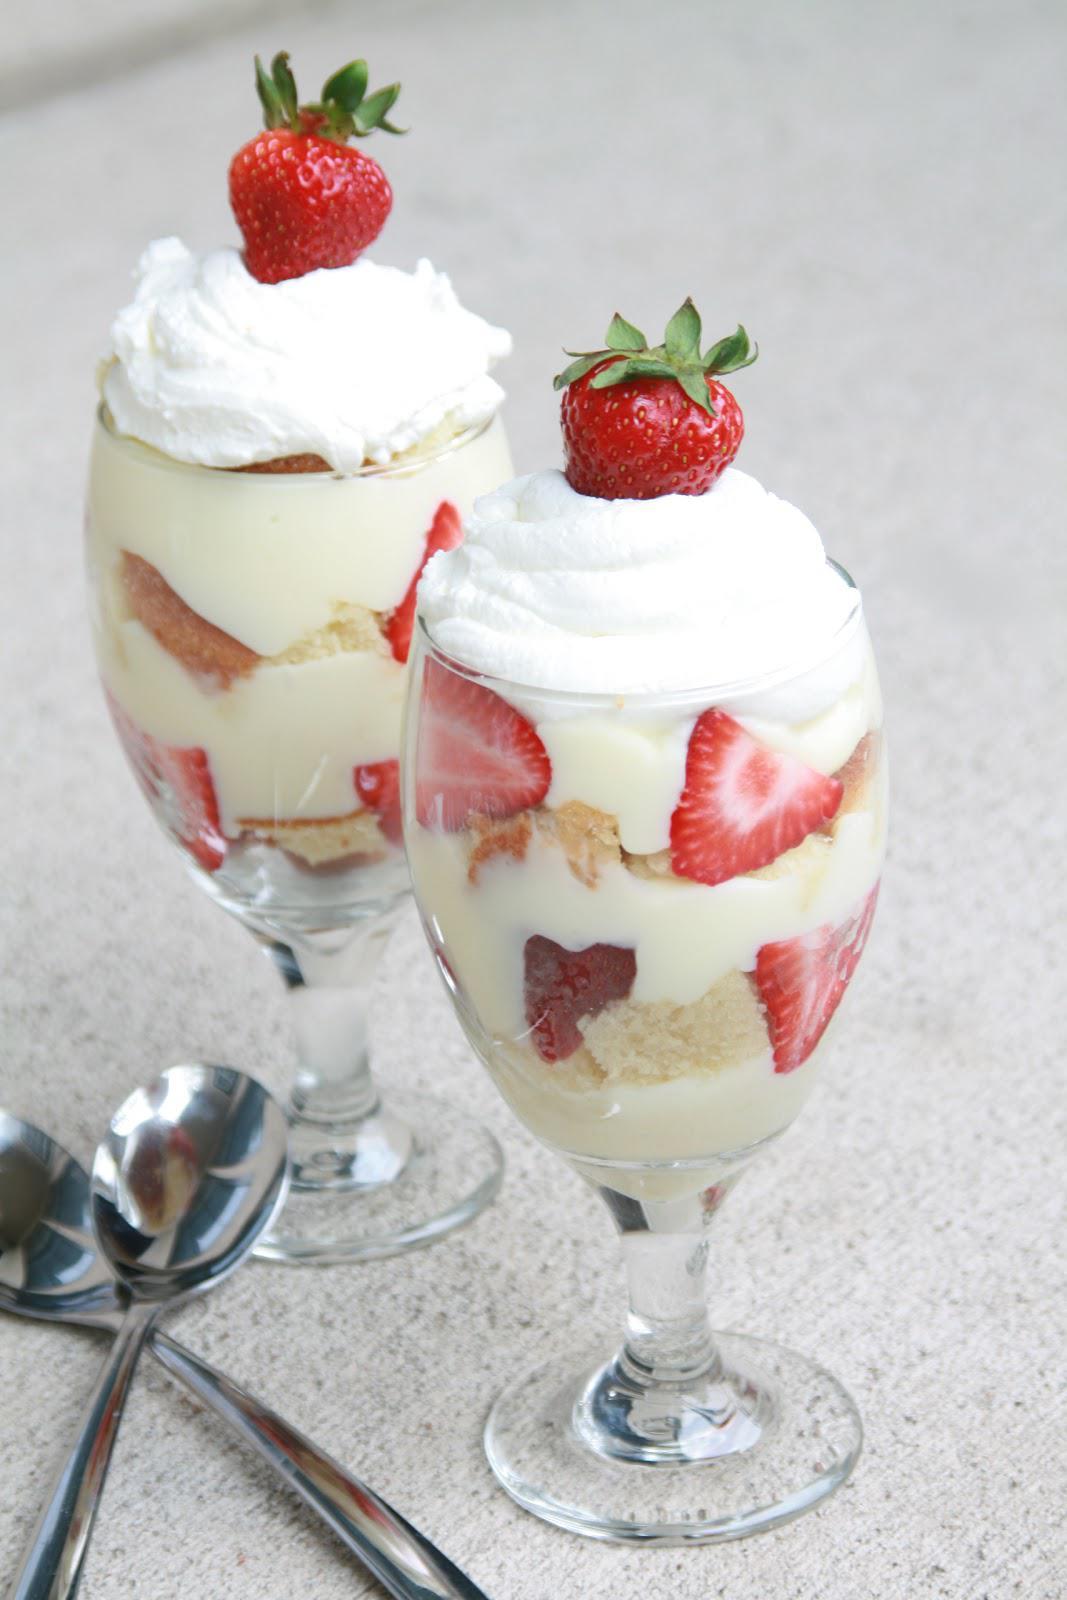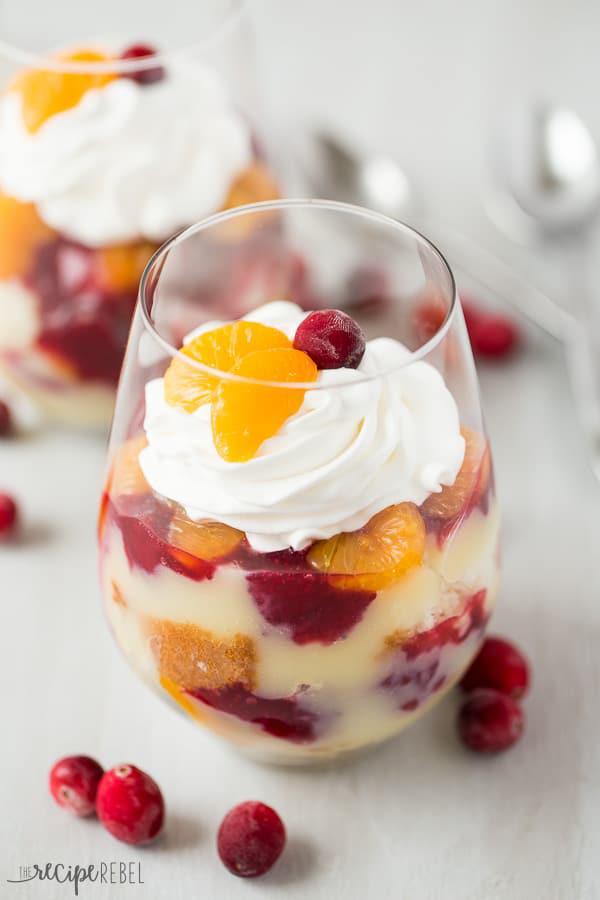The first image is the image on the left, the second image is the image on the right. For the images shown, is this caption "The left image shows one dessert with one spoon." true? Answer yes or no. No. 